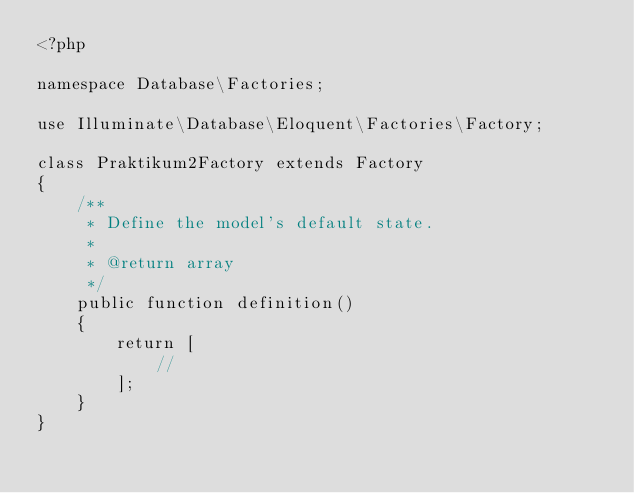Convert code to text. <code><loc_0><loc_0><loc_500><loc_500><_PHP_><?php

namespace Database\Factories;

use Illuminate\Database\Eloquent\Factories\Factory;

class Praktikum2Factory extends Factory
{
    /**
     * Define the model's default state.
     *
     * @return array
     */
    public function definition()
    {
        return [
            //
        ];
    }
}
</code> 